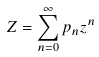<formula> <loc_0><loc_0><loc_500><loc_500>Z = \sum _ { n = 0 } ^ { \infty } p _ { n } z ^ { n }</formula> 